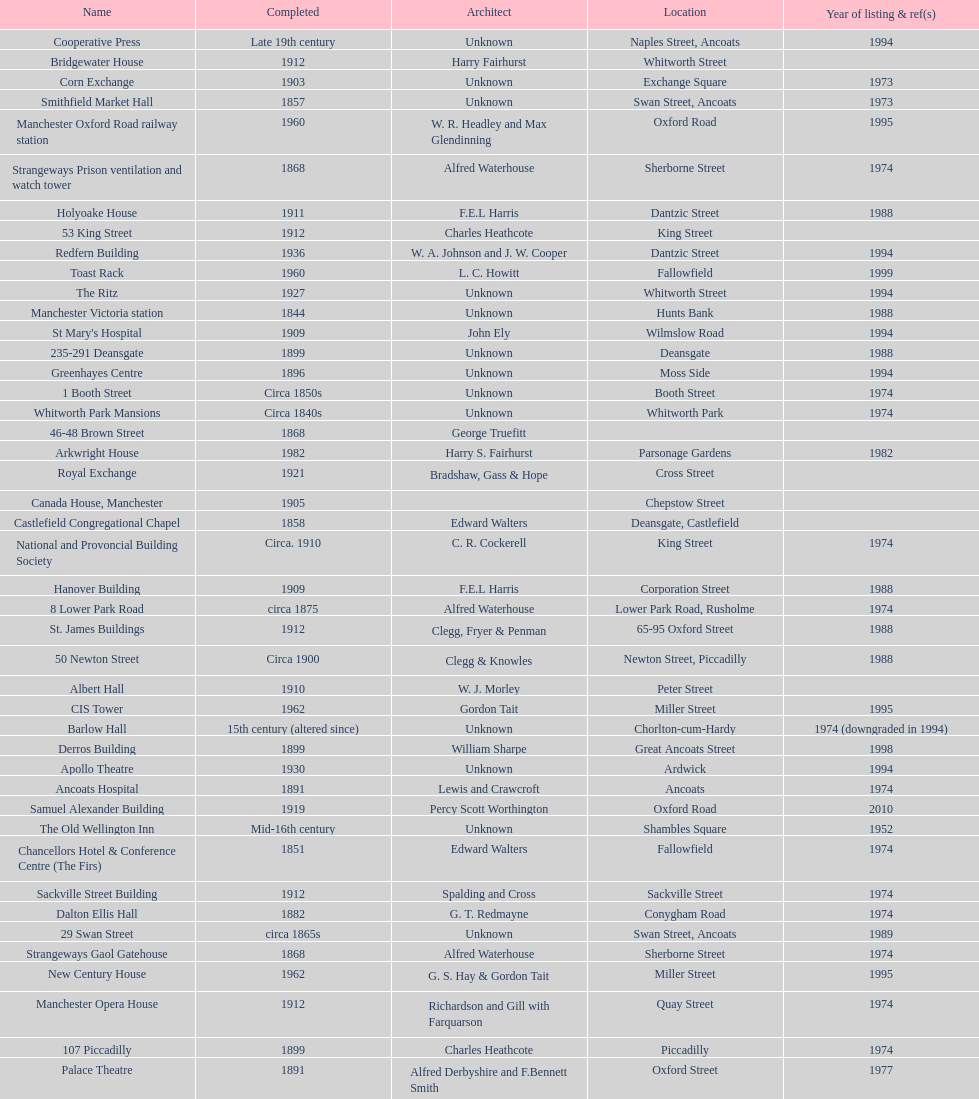How many buildings do not have an image listed? 11. Give me the full table as a dictionary. {'header': ['Name', 'Completed', 'Architect', 'Location', 'Year of listing & ref(s)'], 'rows': [['Cooperative Press', 'Late 19th century', 'Unknown', 'Naples Street, Ancoats', '1994'], ['Bridgewater House', '1912', 'Harry Fairhurst', 'Whitworth Street', ''], ['Corn Exchange', '1903', 'Unknown', 'Exchange Square', '1973'], ['Smithfield Market Hall', '1857', 'Unknown', 'Swan Street, Ancoats', '1973'], ['Manchester Oxford Road railway station', '1960', 'W. R. Headley and Max Glendinning', 'Oxford Road', '1995'], ['Strangeways Prison ventilation and watch tower', '1868', 'Alfred Waterhouse', 'Sherborne Street', '1974'], ['Holyoake House', '1911', 'F.E.L Harris', 'Dantzic Street', '1988'], ['53 King Street', '1912', 'Charles Heathcote', 'King Street', ''], ['Redfern Building', '1936', 'W. A. Johnson and J. W. Cooper', 'Dantzic Street', '1994'], ['Toast Rack', '1960', 'L. C. Howitt', 'Fallowfield', '1999'], ['The Ritz', '1927', 'Unknown', 'Whitworth Street', '1994'], ['Manchester Victoria station', '1844', 'Unknown', 'Hunts Bank', '1988'], ["St Mary's Hospital", '1909', 'John Ely', 'Wilmslow Road', '1994'], ['235-291 Deansgate', '1899', 'Unknown', 'Deansgate', '1988'], ['Greenhayes Centre', '1896', 'Unknown', 'Moss Side', '1994'], ['1 Booth Street', 'Circa 1850s', 'Unknown', 'Booth Street', '1974'], ['Whitworth Park Mansions', 'Circa 1840s', 'Unknown', 'Whitworth Park', '1974'], ['46-48 Brown Street', '1868', 'George Truefitt', '', ''], ['Arkwright House', '1982', 'Harry S. Fairhurst', 'Parsonage Gardens', '1982'], ['Royal Exchange', '1921', 'Bradshaw, Gass & Hope', 'Cross Street', ''], ['Canada House, Manchester', '1905', '', 'Chepstow Street', ''], ['Castlefield Congregational Chapel', '1858', 'Edward Walters', 'Deansgate, Castlefield', ''], ['National and Provoncial Building Society', 'Circa. 1910', 'C. R. Cockerell', 'King Street', '1974'], ['Hanover Building', '1909', 'F.E.L Harris', 'Corporation Street', '1988'], ['8 Lower Park Road', 'circa 1875', 'Alfred Waterhouse', 'Lower Park Road, Rusholme', '1974'], ['St. James Buildings', '1912', 'Clegg, Fryer & Penman', '65-95 Oxford Street', '1988'], ['50 Newton Street', 'Circa 1900', 'Clegg & Knowles', 'Newton Street, Piccadilly', '1988'], ['Albert Hall', '1910', 'W. J. Morley', 'Peter Street', ''], ['CIS Tower', '1962', 'Gordon Tait', 'Miller Street', '1995'], ['Barlow Hall', '15th century (altered since)', 'Unknown', 'Chorlton-cum-Hardy', '1974 (downgraded in 1994)'], ['Derros Building', '1899', 'William Sharpe', 'Great Ancoats Street', '1998'], ['Apollo Theatre', '1930', 'Unknown', 'Ardwick', '1994'], ['Ancoats Hospital', '1891', 'Lewis and Crawcroft', 'Ancoats', '1974'], ['Samuel Alexander Building', '1919', 'Percy Scott Worthington', 'Oxford Road', '2010'], ['The Old Wellington Inn', 'Mid-16th century', 'Unknown', 'Shambles Square', '1952'], ['Chancellors Hotel & Conference Centre (The Firs)', '1851', 'Edward Walters', 'Fallowfield', '1974'], ['Sackville Street Building', '1912', 'Spalding and Cross', 'Sackville Street', '1974'], ['Dalton Ellis Hall', '1882', 'G. T. Redmayne', 'Conygham Road', '1974'], ['29 Swan Street', 'circa 1865s', 'Unknown', 'Swan Street, Ancoats', '1989'], ['Strangeways Gaol Gatehouse', '1868', 'Alfred Waterhouse', 'Sherborne Street', '1974'], ['New Century House', '1962', 'G. S. Hay & Gordon Tait', 'Miller Street', '1995'], ['Manchester Opera House', '1912', 'Richardson and Gill with Farquarson', 'Quay Street', '1974'], ['107 Piccadilly', '1899', 'Charles Heathcote', 'Piccadilly', '1974'], ['Palace Theatre', '1891', 'Alfred Derbyshire and F.Bennett Smith', 'Oxford Street', '1977'], ['Barnes Hospital', '1875', 'Lawrence Booth', 'Didsbury', '1998'], ['Ship Canal House', '1927', 'Harry S. Fairhurst', 'King Street', '1982'], ['Manchester Deansgate railway station', '1896', 'Unknown', '', '1998'], ['Manchester Piccadilly station Store Street train shed', '1881', 'Unknown', 'Piccadilly', '1994'], ['Chancellors Hotel & Conference Centre (The Firs Gate Lodge)', '1851', 'Edward Walters', 'Fallowfield', '1974'], ['Theatre Royal', '1845', 'Irwin and Chester', 'Peter Street', '1974']]} 